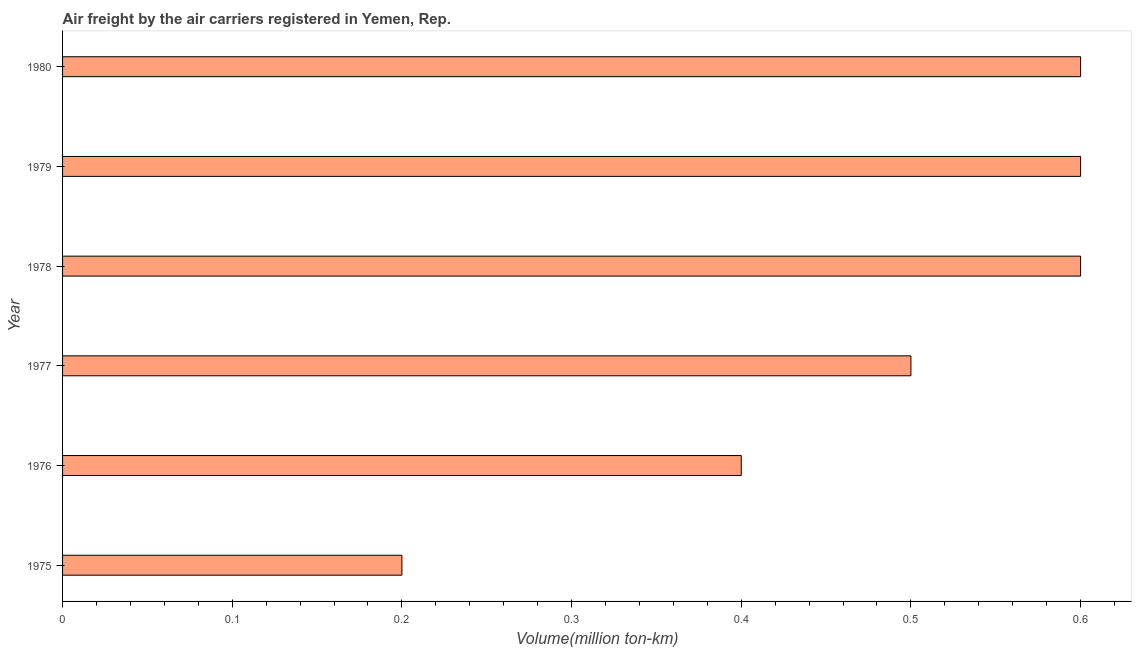Does the graph contain any zero values?
Provide a short and direct response. No. Does the graph contain grids?
Give a very brief answer. No. What is the title of the graph?
Your response must be concise. Air freight by the air carriers registered in Yemen, Rep. What is the label or title of the X-axis?
Your answer should be compact. Volume(million ton-km). What is the label or title of the Y-axis?
Offer a very short reply. Year. What is the air freight in 1975?
Offer a terse response. 0.2. Across all years, what is the maximum air freight?
Give a very brief answer. 0.6. Across all years, what is the minimum air freight?
Offer a very short reply. 0.2. In which year was the air freight maximum?
Keep it short and to the point. 1978. In which year was the air freight minimum?
Keep it short and to the point. 1975. What is the sum of the air freight?
Your response must be concise. 2.9. What is the difference between the air freight in 1978 and 1979?
Keep it short and to the point. 0. What is the average air freight per year?
Keep it short and to the point. 0.48. What is the median air freight?
Your answer should be compact. 0.55. What is the ratio of the air freight in 1976 to that in 1978?
Give a very brief answer. 0.67. Is the air freight in 1975 less than that in 1976?
Your answer should be compact. Yes. What is the difference between the highest and the lowest air freight?
Provide a short and direct response. 0.4. How many bars are there?
Your response must be concise. 6. Are the values on the major ticks of X-axis written in scientific E-notation?
Your answer should be very brief. No. What is the Volume(million ton-km) of 1975?
Give a very brief answer. 0.2. What is the Volume(million ton-km) of 1976?
Keep it short and to the point. 0.4. What is the Volume(million ton-km) in 1978?
Offer a terse response. 0.6. What is the Volume(million ton-km) in 1979?
Offer a terse response. 0.6. What is the Volume(million ton-km) in 1980?
Your response must be concise. 0.6. What is the difference between the Volume(million ton-km) in 1975 and 1976?
Make the answer very short. -0.2. What is the difference between the Volume(million ton-km) in 1975 and 1977?
Your answer should be very brief. -0.3. What is the difference between the Volume(million ton-km) in 1976 and 1979?
Make the answer very short. -0.2. What is the difference between the Volume(million ton-km) in 1977 and 1980?
Your answer should be compact. -0.1. What is the difference between the Volume(million ton-km) in 1979 and 1980?
Give a very brief answer. 0. What is the ratio of the Volume(million ton-km) in 1975 to that in 1976?
Keep it short and to the point. 0.5. What is the ratio of the Volume(million ton-km) in 1975 to that in 1977?
Keep it short and to the point. 0.4. What is the ratio of the Volume(million ton-km) in 1975 to that in 1978?
Provide a succinct answer. 0.33. What is the ratio of the Volume(million ton-km) in 1975 to that in 1979?
Make the answer very short. 0.33. What is the ratio of the Volume(million ton-km) in 1975 to that in 1980?
Provide a succinct answer. 0.33. What is the ratio of the Volume(million ton-km) in 1976 to that in 1977?
Ensure brevity in your answer.  0.8. What is the ratio of the Volume(million ton-km) in 1976 to that in 1978?
Provide a succinct answer. 0.67. What is the ratio of the Volume(million ton-km) in 1976 to that in 1979?
Ensure brevity in your answer.  0.67. What is the ratio of the Volume(million ton-km) in 1976 to that in 1980?
Your answer should be compact. 0.67. What is the ratio of the Volume(million ton-km) in 1977 to that in 1978?
Ensure brevity in your answer.  0.83. What is the ratio of the Volume(million ton-km) in 1977 to that in 1979?
Keep it short and to the point. 0.83. What is the ratio of the Volume(million ton-km) in 1977 to that in 1980?
Your response must be concise. 0.83. What is the ratio of the Volume(million ton-km) in 1978 to that in 1979?
Give a very brief answer. 1. What is the ratio of the Volume(million ton-km) in 1978 to that in 1980?
Provide a short and direct response. 1. What is the ratio of the Volume(million ton-km) in 1979 to that in 1980?
Your answer should be compact. 1. 